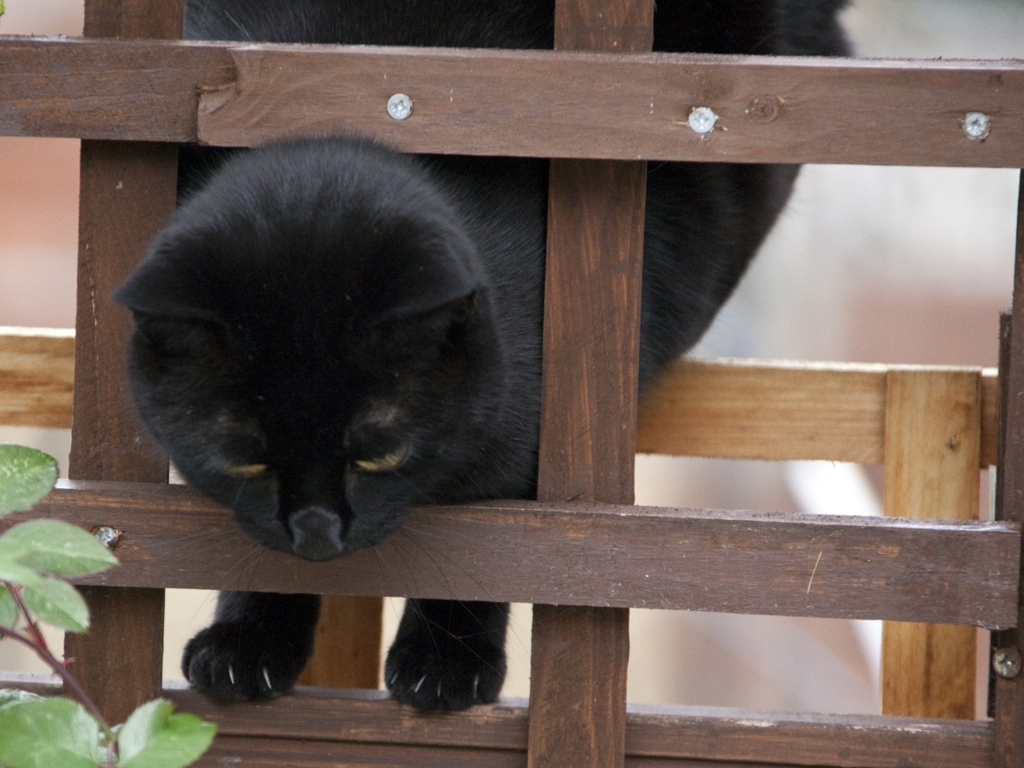Are the textures of the main subject clear? Yes, the textures of the main subject, which appears to be a black cat, are quite clear. One can make out the sheen of its fur and the subtle variations in color. The eyes of the cat reflect light, giving them a vivid appearance, and the wooden lattice also shows distinct textures and wood grain. 